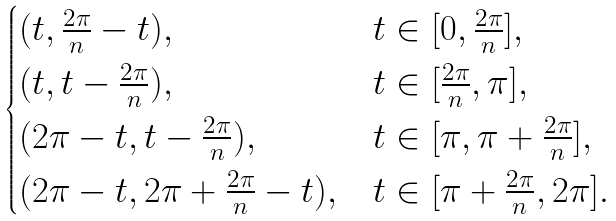<formula> <loc_0><loc_0><loc_500><loc_500>\begin{cases} ( t , \frac { 2 \pi } n - t ) , & t \in [ 0 , \frac { 2 \pi } n ] , \\ ( t , t - \frac { 2 \pi } n ) , & t \in [ \frac { 2 \pi } n , \pi ] , \\ ( 2 \pi - t , t - \frac { 2 \pi } n ) , & t \in [ \pi , \pi + \frac { 2 \pi } n ] , \\ ( 2 \pi - t , 2 \pi + \frac { 2 \pi } n - t ) , & t \in [ \pi + \frac { 2 \pi } n , 2 \pi ] . \\ \end{cases}</formula> 